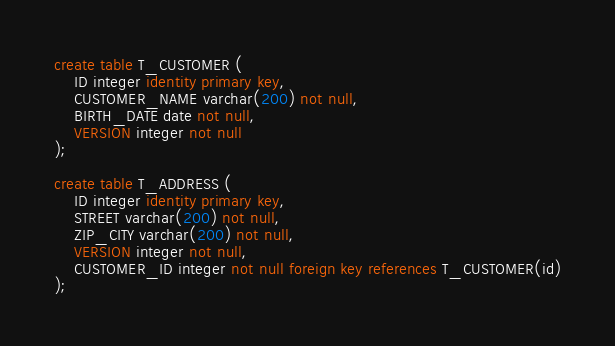<code> <loc_0><loc_0><loc_500><loc_500><_SQL_>create table T_CUSTOMER (
    ID integer identity primary key, 
    CUSTOMER_NAME varchar(200) not null,
    BIRTH_DATE date not null,
    VERSION integer not null
);

create table T_ADDRESS (
    ID integer identity primary key,
    STREET varchar(200) not null,
    ZIP_CITY varchar(200) not null,
    VERSION integer not null,
    CUSTOMER_ID integer not null foreign key references T_CUSTOMER(id)
);</code> 